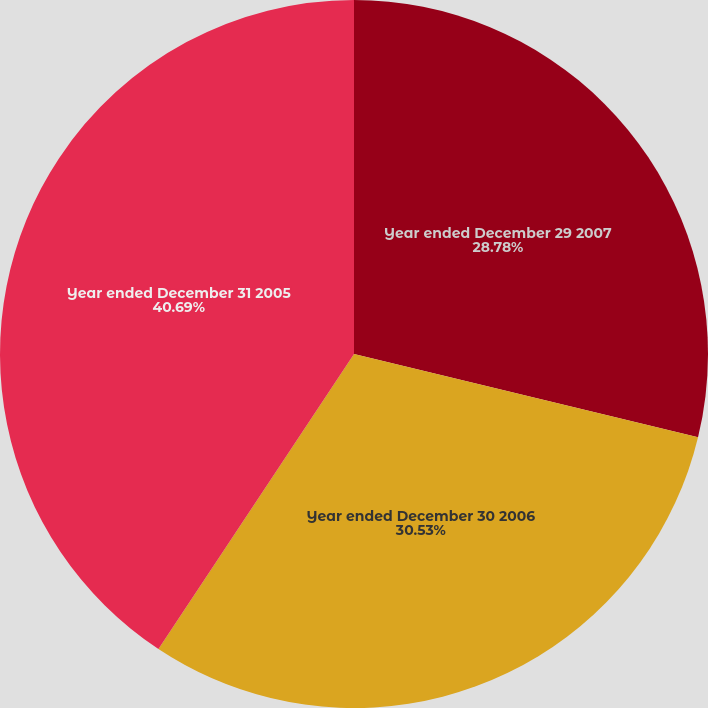Convert chart to OTSL. <chart><loc_0><loc_0><loc_500><loc_500><pie_chart><fcel>Year ended December 29 2007<fcel>Year ended December 30 2006<fcel>Year ended December 31 2005<nl><fcel>28.78%<fcel>30.53%<fcel>40.68%<nl></chart> 